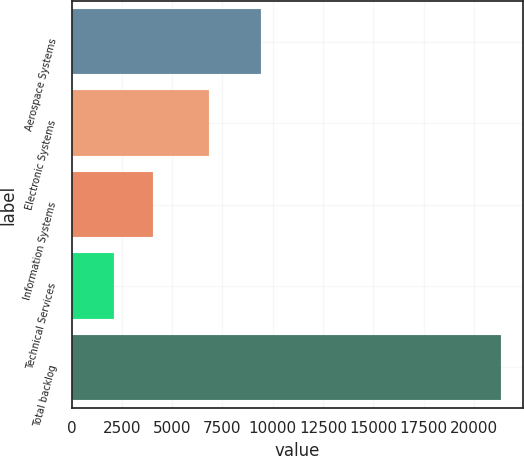Convert chart to OTSL. <chart><loc_0><loc_0><loc_500><loc_500><bar_chart><fcel>Aerospace Systems<fcel>Electronic Systems<fcel>Information Systems<fcel>Technical Services<fcel>Total backlog<nl><fcel>9438<fcel>6845<fcel>4051.6<fcel>2127<fcel>21373<nl></chart> 